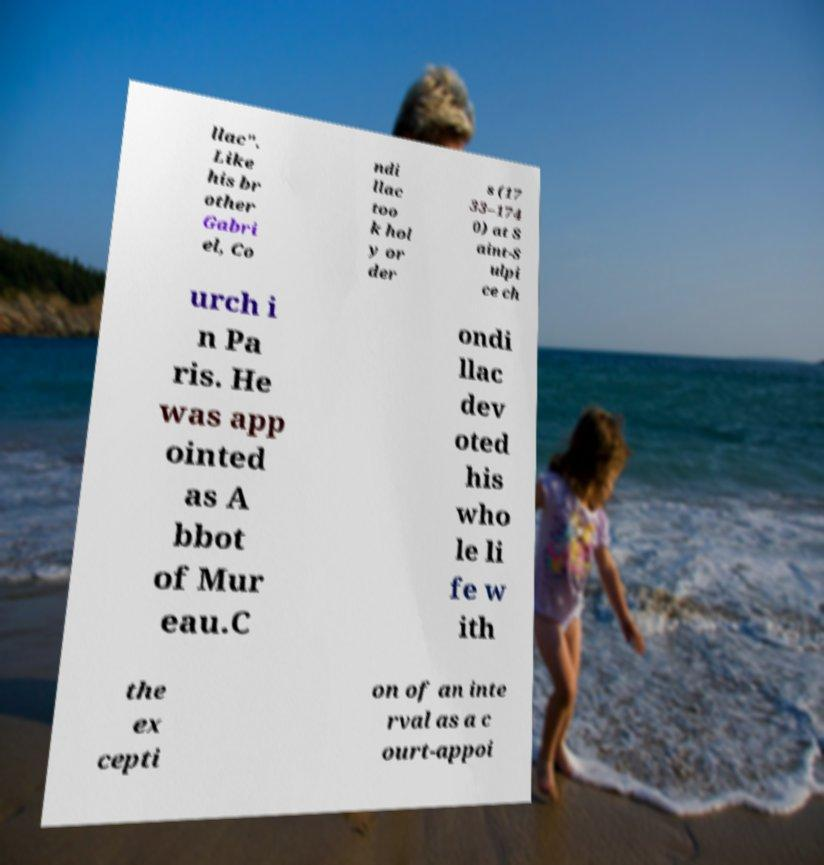Can you read and provide the text displayed in the image?This photo seems to have some interesting text. Can you extract and type it out for me? llac". Like his br other Gabri el, Co ndi llac too k hol y or der s (17 33–174 0) at S aint-S ulpi ce ch urch i n Pa ris. He was app ointed as A bbot of Mur eau.C ondi llac dev oted his who le li fe w ith the ex cepti on of an inte rval as a c ourt-appoi 